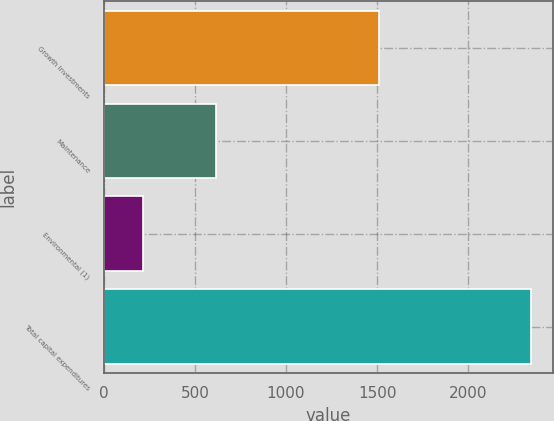Convert chart to OTSL. <chart><loc_0><loc_0><loc_500><loc_500><bar_chart><fcel>Growth Investments<fcel>Maintenance<fcel>Environmental (1)<fcel>Total capital expenditures<nl><fcel>1510<fcel>617<fcel>218<fcel>2345<nl></chart> 